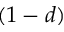<formula> <loc_0><loc_0><loc_500><loc_500>( 1 - d )</formula> 